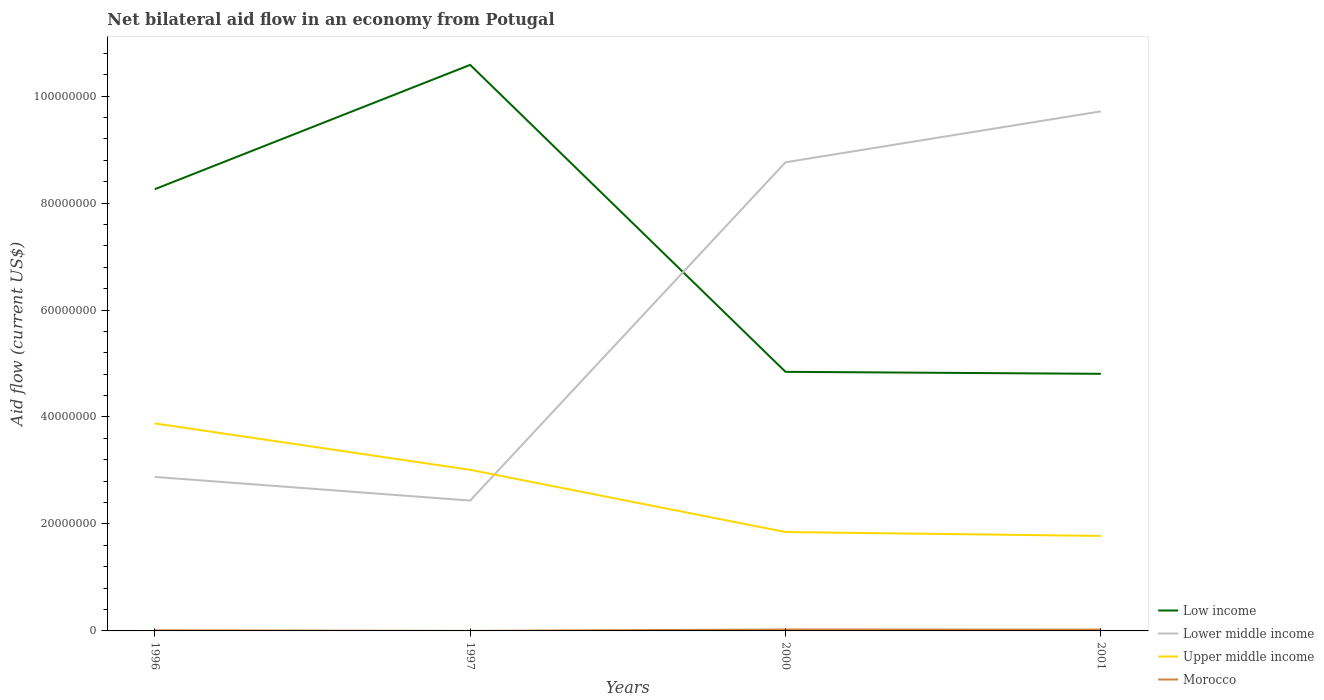Across all years, what is the maximum net bilateral aid flow in Upper middle income?
Your response must be concise. 1.78e+07. In which year was the net bilateral aid flow in Upper middle income maximum?
Give a very brief answer. 2001. What is the total net bilateral aid flow in Lower middle income in the graph?
Your answer should be very brief. -9.52e+06. What is the difference between the highest and the second highest net bilateral aid flow in Lower middle income?
Offer a very short reply. 7.28e+07. How many years are there in the graph?
Offer a very short reply. 4. Are the values on the major ticks of Y-axis written in scientific E-notation?
Your response must be concise. No. Does the graph contain any zero values?
Your response must be concise. No. How are the legend labels stacked?
Your answer should be very brief. Vertical. What is the title of the graph?
Your answer should be compact. Net bilateral aid flow in an economy from Potugal. What is the label or title of the X-axis?
Make the answer very short. Years. What is the label or title of the Y-axis?
Make the answer very short. Aid flow (current US$). What is the Aid flow (current US$) in Low income in 1996?
Provide a short and direct response. 8.26e+07. What is the Aid flow (current US$) in Lower middle income in 1996?
Your answer should be very brief. 2.88e+07. What is the Aid flow (current US$) of Upper middle income in 1996?
Provide a short and direct response. 3.88e+07. What is the Aid flow (current US$) in Low income in 1997?
Provide a succinct answer. 1.06e+08. What is the Aid flow (current US$) of Lower middle income in 1997?
Give a very brief answer. 2.44e+07. What is the Aid flow (current US$) in Upper middle income in 1997?
Your answer should be very brief. 3.01e+07. What is the Aid flow (current US$) of Low income in 2000?
Keep it short and to the point. 4.84e+07. What is the Aid flow (current US$) in Lower middle income in 2000?
Offer a very short reply. 8.76e+07. What is the Aid flow (current US$) of Upper middle income in 2000?
Ensure brevity in your answer.  1.85e+07. What is the Aid flow (current US$) in Low income in 2001?
Make the answer very short. 4.81e+07. What is the Aid flow (current US$) in Lower middle income in 2001?
Your answer should be very brief. 9.71e+07. What is the Aid flow (current US$) of Upper middle income in 2001?
Provide a short and direct response. 1.78e+07. What is the Aid flow (current US$) in Morocco in 2001?
Offer a very short reply. 2.50e+05. Across all years, what is the maximum Aid flow (current US$) in Low income?
Your answer should be compact. 1.06e+08. Across all years, what is the maximum Aid flow (current US$) in Lower middle income?
Offer a very short reply. 9.71e+07. Across all years, what is the maximum Aid flow (current US$) of Upper middle income?
Make the answer very short. 3.88e+07. Across all years, what is the minimum Aid flow (current US$) of Low income?
Keep it short and to the point. 4.81e+07. Across all years, what is the minimum Aid flow (current US$) of Lower middle income?
Give a very brief answer. 2.44e+07. Across all years, what is the minimum Aid flow (current US$) in Upper middle income?
Keep it short and to the point. 1.78e+07. Across all years, what is the minimum Aid flow (current US$) in Morocco?
Provide a short and direct response. 10000. What is the total Aid flow (current US$) of Low income in the graph?
Keep it short and to the point. 2.85e+08. What is the total Aid flow (current US$) in Lower middle income in the graph?
Your response must be concise. 2.38e+08. What is the total Aid flow (current US$) of Upper middle income in the graph?
Ensure brevity in your answer.  1.05e+08. What is the total Aid flow (current US$) in Morocco in the graph?
Your response must be concise. 6.40e+05. What is the difference between the Aid flow (current US$) of Low income in 1996 and that in 1997?
Ensure brevity in your answer.  -2.32e+07. What is the difference between the Aid flow (current US$) of Lower middle income in 1996 and that in 1997?
Your answer should be very brief. 4.42e+06. What is the difference between the Aid flow (current US$) in Upper middle income in 1996 and that in 1997?
Give a very brief answer. 8.68e+06. What is the difference between the Aid flow (current US$) in Morocco in 1996 and that in 1997?
Ensure brevity in your answer.  1.00e+05. What is the difference between the Aid flow (current US$) in Low income in 1996 and that in 2000?
Provide a short and direct response. 3.42e+07. What is the difference between the Aid flow (current US$) in Lower middle income in 1996 and that in 2000?
Give a very brief answer. -5.88e+07. What is the difference between the Aid flow (current US$) in Upper middle income in 1996 and that in 2000?
Give a very brief answer. 2.03e+07. What is the difference between the Aid flow (current US$) in Low income in 1996 and that in 2001?
Offer a very short reply. 3.45e+07. What is the difference between the Aid flow (current US$) of Lower middle income in 1996 and that in 2001?
Offer a terse response. -6.84e+07. What is the difference between the Aid flow (current US$) of Upper middle income in 1996 and that in 2001?
Offer a terse response. 2.10e+07. What is the difference between the Aid flow (current US$) in Low income in 1997 and that in 2000?
Make the answer very short. 5.74e+07. What is the difference between the Aid flow (current US$) of Lower middle income in 1997 and that in 2000?
Offer a very short reply. -6.32e+07. What is the difference between the Aid flow (current US$) of Upper middle income in 1997 and that in 2000?
Ensure brevity in your answer.  1.16e+07. What is the difference between the Aid flow (current US$) in Low income in 1997 and that in 2001?
Your answer should be compact. 5.78e+07. What is the difference between the Aid flow (current US$) in Lower middle income in 1997 and that in 2001?
Keep it short and to the point. -7.28e+07. What is the difference between the Aid flow (current US$) in Upper middle income in 1997 and that in 2001?
Provide a succinct answer. 1.24e+07. What is the difference between the Aid flow (current US$) of Morocco in 1997 and that in 2001?
Ensure brevity in your answer.  -2.40e+05. What is the difference between the Aid flow (current US$) in Lower middle income in 2000 and that in 2001?
Provide a succinct answer. -9.52e+06. What is the difference between the Aid flow (current US$) in Upper middle income in 2000 and that in 2001?
Offer a very short reply. 7.30e+05. What is the difference between the Aid flow (current US$) in Low income in 1996 and the Aid flow (current US$) in Lower middle income in 1997?
Give a very brief answer. 5.82e+07. What is the difference between the Aid flow (current US$) in Low income in 1996 and the Aid flow (current US$) in Upper middle income in 1997?
Give a very brief answer. 5.25e+07. What is the difference between the Aid flow (current US$) in Low income in 1996 and the Aid flow (current US$) in Morocco in 1997?
Provide a succinct answer. 8.26e+07. What is the difference between the Aid flow (current US$) of Lower middle income in 1996 and the Aid flow (current US$) of Upper middle income in 1997?
Give a very brief answer. -1.33e+06. What is the difference between the Aid flow (current US$) of Lower middle income in 1996 and the Aid flow (current US$) of Morocco in 1997?
Your response must be concise. 2.88e+07. What is the difference between the Aid flow (current US$) in Upper middle income in 1996 and the Aid flow (current US$) in Morocco in 1997?
Give a very brief answer. 3.88e+07. What is the difference between the Aid flow (current US$) of Low income in 1996 and the Aid flow (current US$) of Lower middle income in 2000?
Offer a very short reply. -5.03e+06. What is the difference between the Aid flow (current US$) of Low income in 1996 and the Aid flow (current US$) of Upper middle income in 2000?
Your response must be concise. 6.41e+07. What is the difference between the Aid flow (current US$) in Low income in 1996 and the Aid flow (current US$) in Morocco in 2000?
Ensure brevity in your answer.  8.23e+07. What is the difference between the Aid flow (current US$) of Lower middle income in 1996 and the Aid flow (current US$) of Upper middle income in 2000?
Provide a succinct answer. 1.03e+07. What is the difference between the Aid flow (current US$) of Lower middle income in 1996 and the Aid flow (current US$) of Morocco in 2000?
Make the answer very short. 2.85e+07. What is the difference between the Aid flow (current US$) of Upper middle income in 1996 and the Aid flow (current US$) of Morocco in 2000?
Give a very brief answer. 3.85e+07. What is the difference between the Aid flow (current US$) in Low income in 1996 and the Aid flow (current US$) in Lower middle income in 2001?
Your answer should be very brief. -1.46e+07. What is the difference between the Aid flow (current US$) in Low income in 1996 and the Aid flow (current US$) in Upper middle income in 2001?
Your answer should be very brief. 6.48e+07. What is the difference between the Aid flow (current US$) of Low income in 1996 and the Aid flow (current US$) of Morocco in 2001?
Provide a succinct answer. 8.23e+07. What is the difference between the Aid flow (current US$) in Lower middle income in 1996 and the Aid flow (current US$) in Upper middle income in 2001?
Provide a succinct answer. 1.10e+07. What is the difference between the Aid flow (current US$) of Lower middle income in 1996 and the Aid flow (current US$) of Morocco in 2001?
Offer a terse response. 2.85e+07. What is the difference between the Aid flow (current US$) of Upper middle income in 1996 and the Aid flow (current US$) of Morocco in 2001?
Your answer should be very brief. 3.86e+07. What is the difference between the Aid flow (current US$) in Low income in 1997 and the Aid flow (current US$) in Lower middle income in 2000?
Make the answer very short. 1.82e+07. What is the difference between the Aid flow (current US$) in Low income in 1997 and the Aid flow (current US$) in Upper middle income in 2000?
Offer a very short reply. 8.73e+07. What is the difference between the Aid flow (current US$) of Low income in 1997 and the Aid flow (current US$) of Morocco in 2000?
Give a very brief answer. 1.06e+08. What is the difference between the Aid flow (current US$) in Lower middle income in 1997 and the Aid flow (current US$) in Upper middle income in 2000?
Your answer should be very brief. 5.88e+06. What is the difference between the Aid flow (current US$) in Lower middle income in 1997 and the Aid flow (current US$) in Morocco in 2000?
Your response must be concise. 2.41e+07. What is the difference between the Aid flow (current US$) in Upper middle income in 1997 and the Aid flow (current US$) in Morocco in 2000?
Offer a very short reply. 2.98e+07. What is the difference between the Aid flow (current US$) of Low income in 1997 and the Aid flow (current US$) of Lower middle income in 2001?
Offer a very short reply. 8.69e+06. What is the difference between the Aid flow (current US$) in Low income in 1997 and the Aid flow (current US$) in Upper middle income in 2001?
Offer a terse response. 8.81e+07. What is the difference between the Aid flow (current US$) of Low income in 1997 and the Aid flow (current US$) of Morocco in 2001?
Ensure brevity in your answer.  1.06e+08. What is the difference between the Aid flow (current US$) in Lower middle income in 1997 and the Aid flow (current US$) in Upper middle income in 2001?
Offer a terse response. 6.61e+06. What is the difference between the Aid flow (current US$) in Lower middle income in 1997 and the Aid flow (current US$) in Morocco in 2001?
Offer a terse response. 2.41e+07. What is the difference between the Aid flow (current US$) in Upper middle income in 1997 and the Aid flow (current US$) in Morocco in 2001?
Offer a very short reply. 2.99e+07. What is the difference between the Aid flow (current US$) of Low income in 2000 and the Aid flow (current US$) of Lower middle income in 2001?
Ensure brevity in your answer.  -4.87e+07. What is the difference between the Aid flow (current US$) of Low income in 2000 and the Aid flow (current US$) of Upper middle income in 2001?
Give a very brief answer. 3.07e+07. What is the difference between the Aid flow (current US$) in Low income in 2000 and the Aid flow (current US$) in Morocco in 2001?
Make the answer very short. 4.82e+07. What is the difference between the Aid flow (current US$) in Lower middle income in 2000 and the Aid flow (current US$) in Upper middle income in 2001?
Give a very brief answer. 6.99e+07. What is the difference between the Aid flow (current US$) in Lower middle income in 2000 and the Aid flow (current US$) in Morocco in 2001?
Offer a terse response. 8.74e+07. What is the difference between the Aid flow (current US$) of Upper middle income in 2000 and the Aid flow (current US$) of Morocco in 2001?
Your answer should be compact. 1.82e+07. What is the average Aid flow (current US$) in Low income per year?
Your answer should be compact. 7.12e+07. What is the average Aid flow (current US$) of Lower middle income per year?
Provide a succinct answer. 5.95e+07. What is the average Aid flow (current US$) in Upper middle income per year?
Provide a short and direct response. 2.63e+07. In the year 1996, what is the difference between the Aid flow (current US$) of Low income and Aid flow (current US$) of Lower middle income?
Make the answer very short. 5.38e+07. In the year 1996, what is the difference between the Aid flow (current US$) in Low income and Aid flow (current US$) in Upper middle income?
Make the answer very short. 4.38e+07. In the year 1996, what is the difference between the Aid flow (current US$) of Low income and Aid flow (current US$) of Morocco?
Offer a very short reply. 8.25e+07. In the year 1996, what is the difference between the Aid flow (current US$) of Lower middle income and Aid flow (current US$) of Upper middle income?
Ensure brevity in your answer.  -1.00e+07. In the year 1996, what is the difference between the Aid flow (current US$) in Lower middle income and Aid flow (current US$) in Morocco?
Offer a very short reply. 2.87e+07. In the year 1996, what is the difference between the Aid flow (current US$) of Upper middle income and Aid flow (current US$) of Morocco?
Provide a short and direct response. 3.87e+07. In the year 1997, what is the difference between the Aid flow (current US$) in Low income and Aid flow (current US$) in Lower middle income?
Your answer should be compact. 8.15e+07. In the year 1997, what is the difference between the Aid flow (current US$) in Low income and Aid flow (current US$) in Upper middle income?
Give a very brief answer. 7.57e+07. In the year 1997, what is the difference between the Aid flow (current US$) in Low income and Aid flow (current US$) in Morocco?
Make the answer very short. 1.06e+08. In the year 1997, what is the difference between the Aid flow (current US$) in Lower middle income and Aid flow (current US$) in Upper middle income?
Provide a short and direct response. -5.75e+06. In the year 1997, what is the difference between the Aid flow (current US$) in Lower middle income and Aid flow (current US$) in Morocco?
Make the answer very short. 2.44e+07. In the year 1997, what is the difference between the Aid flow (current US$) of Upper middle income and Aid flow (current US$) of Morocco?
Your response must be concise. 3.01e+07. In the year 2000, what is the difference between the Aid flow (current US$) in Low income and Aid flow (current US$) in Lower middle income?
Provide a short and direct response. -3.92e+07. In the year 2000, what is the difference between the Aid flow (current US$) of Low income and Aid flow (current US$) of Upper middle income?
Ensure brevity in your answer.  3.00e+07. In the year 2000, what is the difference between the Aid flow (current US$) of Low income and Aid flow (current US$) of Morocco?
Your answer should be very brief. 4.82e+07. In the year 2000, what is the difference between the Aid flow (current US$) of Lower middle income and Aid flow (current US$) of Upper middle income?
Provide a succinct answer. 6.91e+07. In the year 2000, what is the difference between the Aid flow (current US$) in Lower middle income and Aid flow (current US$) in Morocco?
Ensure brevity in your answer.  8.74e+07. In the year 2000, what is the difference between the Aid flow (current US$) of Upper middle income and Aid flow (current US$) of Morocco?
Your response must be concise. 1.82e+07. In the year 2001, what is the difference between the Aid flow (current US$) of Low income and Aid flow (current US$) of Lower middle income?
Your answer should be very brief. -4.91e+07. In the year 2001, what is the difference between the Aid flow (current US$) in Low income and Aid flow (current US$) in Upper middle income?
Your answer should be compact. 3.03e+07. In the year 2001, what is the difference between the Aid flow (current US$) in Low income and Aid flow (current US$) in Morocco?
Give a very brief answer. 4.78e+07. In the year 2001, what is the difference between the Aid flow (current US$) of Lower middle income and Aid flow (current US$) of Upper middle income?
Your answer should be compact. 7.94e+07. In the year 2001, what is the difference between the Aid flow (current US$) in Lower middle income and Aid flow (current US$) in Morocco?
Offer a terse response. 9.69e+07. In the year 2001, what is the difference between the Aid flow (current US$) of Upper middle income and Aid flow (current US$) of Morocco?
Your response must be concise. 1.75e+07. What is the ratio of the Aid flow (current US$) of Low income in 1996 to that in 1997?
Give a very brief answer. 0.78. What is the ratio of the Aid flow (current US$) of Lower middle income in 1996 to that in 1997?
Your answer should be very brief. 1.18. What is the ratio of the Aid flow (current US$) in Upper middle income in 1996 to that in 1997?
Your answer should be compact. 1.29. What is the ratio of the Aid flow (current US$) of Low income in 1996 to that in 2000?
Keep it short and to the point. 1.71. What is the ratio of the Aid flow (current US$) of Lower middle income in 1996 to that in 2000?
Provide a succinct answer. 0.33. What is the ratio of the Aid flow (current US$) of Upper middle income in 1996 to that in 2000?
Make the answer very short. 2.1. What is the ratio of the Aid flow (current US$) in Morocco in 1996 to that in 2000?
Offer a very short reply. 0.41. What is the ratio of the Aid flow (current US$) in Low income in 1996 to that in 2001?
Provide a short and direct response. 1.72. What is the ratio of the Aid flow (current US$) of Lower middle income in 1996 to that in 2001?
Provide a succinct answer. 0.3. What is the ratio of the Aid flow (current US$) in Upper middle income in 1996 to that in 2001?
Keep it short and to the point. 2.18. What is the ratio of the Aid flow (current US$) of Morocco in 1996 to that in 2001?
Your answer should be very brief. 0.44. What is the ratio of the Aid flow (current US$) in Low income in 1997 to that in 2000?
Keep it short and to the point. 2.18. What is the ratio of the Aid flow (current US$) of Lower middle income in 1997 to that in 2000?
Your response must be concise. 0.28. What is the ratio of the Aid flow (current US$) in Upper middle income in 1997 to that in 2000?
Make the answer very short. 1.63. What is the ratio of the Aid flow (current US$) in Morocco in 1997 to that in 2000?
Offer a very short reply. 0.04. What is the ratio of the Aid flow (current US$) of Low income in 1997 to that in 2001?
Make the answer very short. 2.2. What is the ratio of the Aid flow (current US$) in Lower middle income in 1997 to that in 2001?
Your answer should be very brief. 0.25. What is the ratio of the Aid flow (current US$) of Upper middle income in 1997 to that in 2001?
Your answer should be compact. 1.7. What is the ratio of the Aid flow (current US$) of Low income in 2000 to that in 2001?
Your answer should be very brief. 1.01. What is the ratio of the Aid flow (current US$) in Lower middle income in 2000 to that in 2001?
Make the answer very short. 0.9. What is the ratio of the Aid flow (current US$) in Upper middle income in 2000 to that in 2001?
Your response must be concise. 1.04. What is the difference between the highest and the second highest Aid flow (current US$) in Low income?
Offer a very short reply. 2.32e+07. What is the difference between the highest and the second highest Aid flow (current US$) in Lower middle income?
Give a very brief answer. 9.52e+06. What is the difference between the highest and the second highest Aid flow (current US$) of Upper middle income?
Make the answer very short. 8.68e+06. What is the difference between the highest and the lowest Aid flow (current US$) of Low income?
Ensure brevity in your answer.  5.78e+07. What is the difference between the highest and the lowest Aid flow (current US$) in Lower middle income?
Give a very brief answer. 7.28e+07. What is the difference between the highest and the lowest Aid flow (current US$) of Upper middle income?
Offer a terse response. 2.10e+07. What is the difference between the highest and the lowest Aid flow (current US$) in Morocco?
Ensure brevity in your answer.  2.60e+05. 